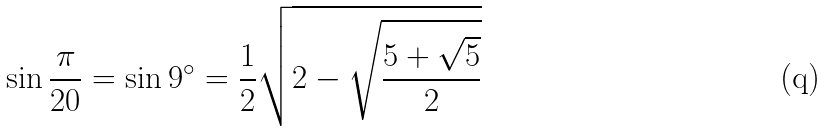<formula> <loc_0><loc_0><loc_500><loc_500>\sin { \frac { \pi } { 2 0 } } = \sin 9 ^ { \circ } = { \frac { 1 } { 2 } } { \sqrt { 2 - { \sqrt { \frac { 5 + { \sqrt { 5 } } } { 2 } } } } }</formula> 